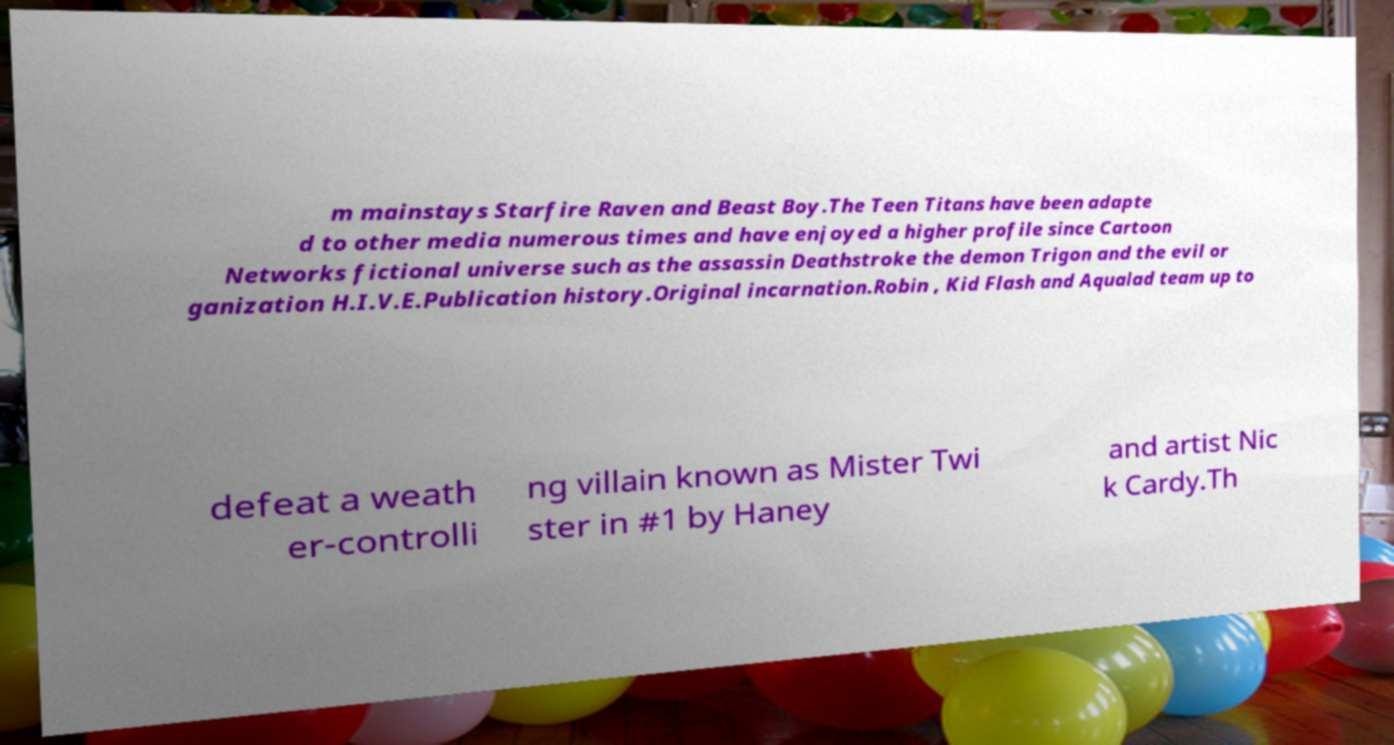Can you read and provide the text displayed in the image?This photo seems to have some interesting text. Can you extract and type it out for me? m mainstays Starfire Raven and Beast Boy.The Teen Titans have been adapte d to other media numerous times and have enjoyed a higher profile since Cartoon Networks fictional universe such as the assassin Deathstroke the demon Trigon and the evil or ganization H.I.V.E.Publication history.Original incarnation.Robin , Kid Flash and Aqualad team up to defeat a weath er-controlli ng villain known as Mister Twi ster in #1 by Haney and artist Nic k Cardy.Th 